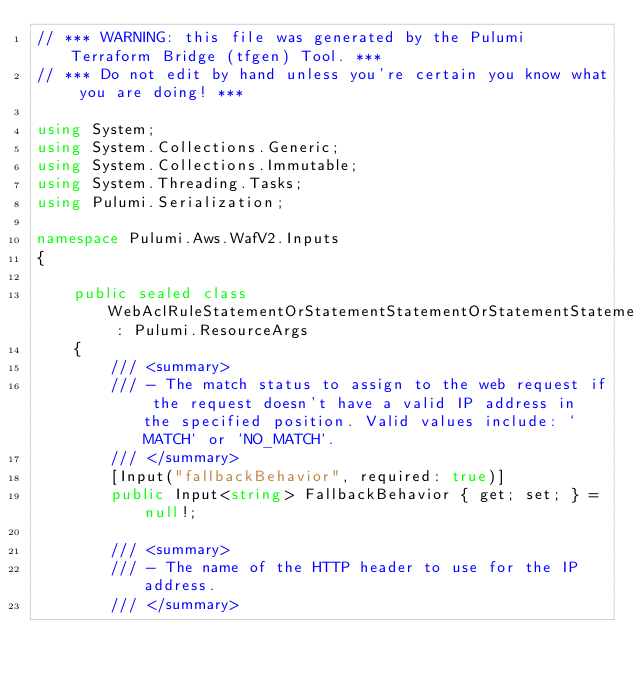Convert code to text. <code><loc_0><loc_0><loc_500><loc_500><_C#_>// *** WARNING: this file was generated by the Pulumi Terraform Bridge (tfgen) Tool. ***
// *** Do not edit by hand unless you're certain you know what you are doing! ***

using System;
using System.Collections.Generic;
using System.Collections.Immutable;
using System.Threading.Tasks;
using Pulumi.Serialization;

namespace Pulumi.Aws.WafV2.Inputs
{

    public sealed class WebAclRuleStatementOrStatementStatementOrStatementStatementGeoMatchStatementForwardedIpConfigGetArgs : Pulumi.ResourceArgs
    {
        /// <summary>
        /// - The match status to assign to the web request if the request doesn't have a valid IP address in the specified position. Valid values include: `MATCH` or `NO_MATCH`.
        /// </summary>
        [Input("fallbackBehavior", required: true)]
        public Input<string> FallbackBehavior { get; set; } = null!;

        /// <summary>
        /// - The name of the HTTP header to use for the IP address.
        /// </summary></code> 